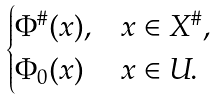<formula> <loc_0><loc_0><loc_500><loc_500>\begin{cases} \Phi ^ { \# } ( x ) , & x \in X ^ { \# } , \\ \Phi _ { 0 } ( x ) & x \in U . \end{cases}</formula> 